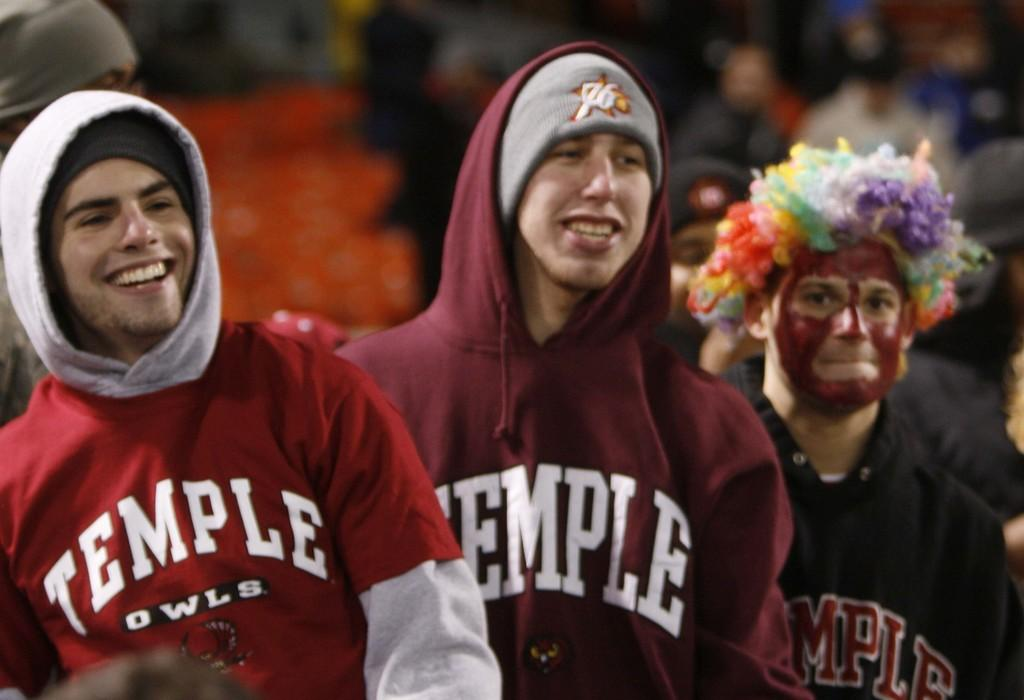<image>
Give a short and clear explanation of the subsequent image. three students of the Temple University wearing their school sweatshirts 